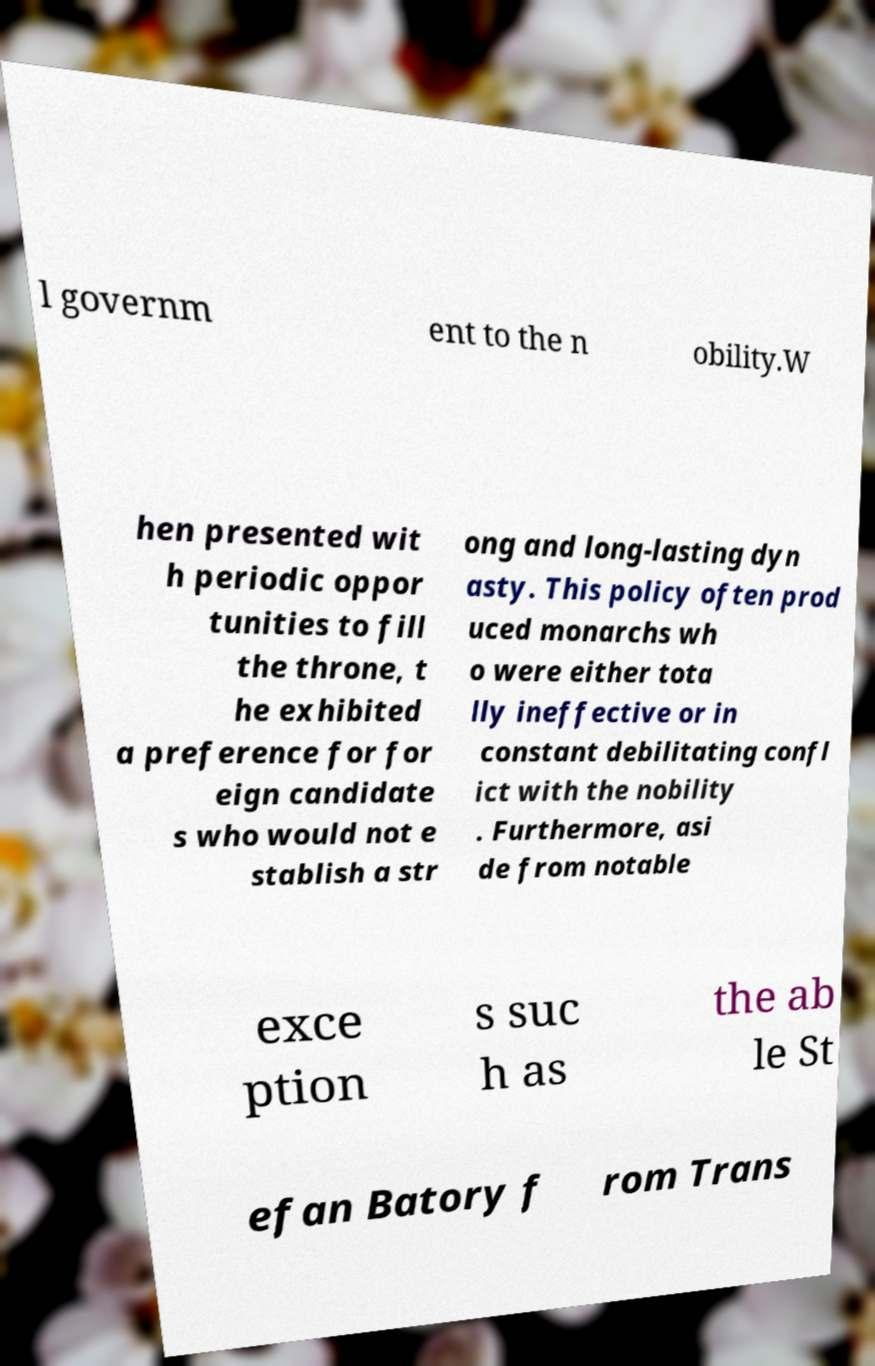Could you extract and type out the text from this image? l governm ent to the n obility.W hen presented wit h periodic oppor tunities to fill the throne, t he exhibited a preference for for eign candidate s who would not e stablish a str ong and long-lasting dyn asty. This policy often prod uced monarchs wh o were either tota lly ineffective or in constant debilitating confl ict with the nobility . Furthermore, asi de from notable exce ption s suc h as the ab le St efan Batory f rom Trans 